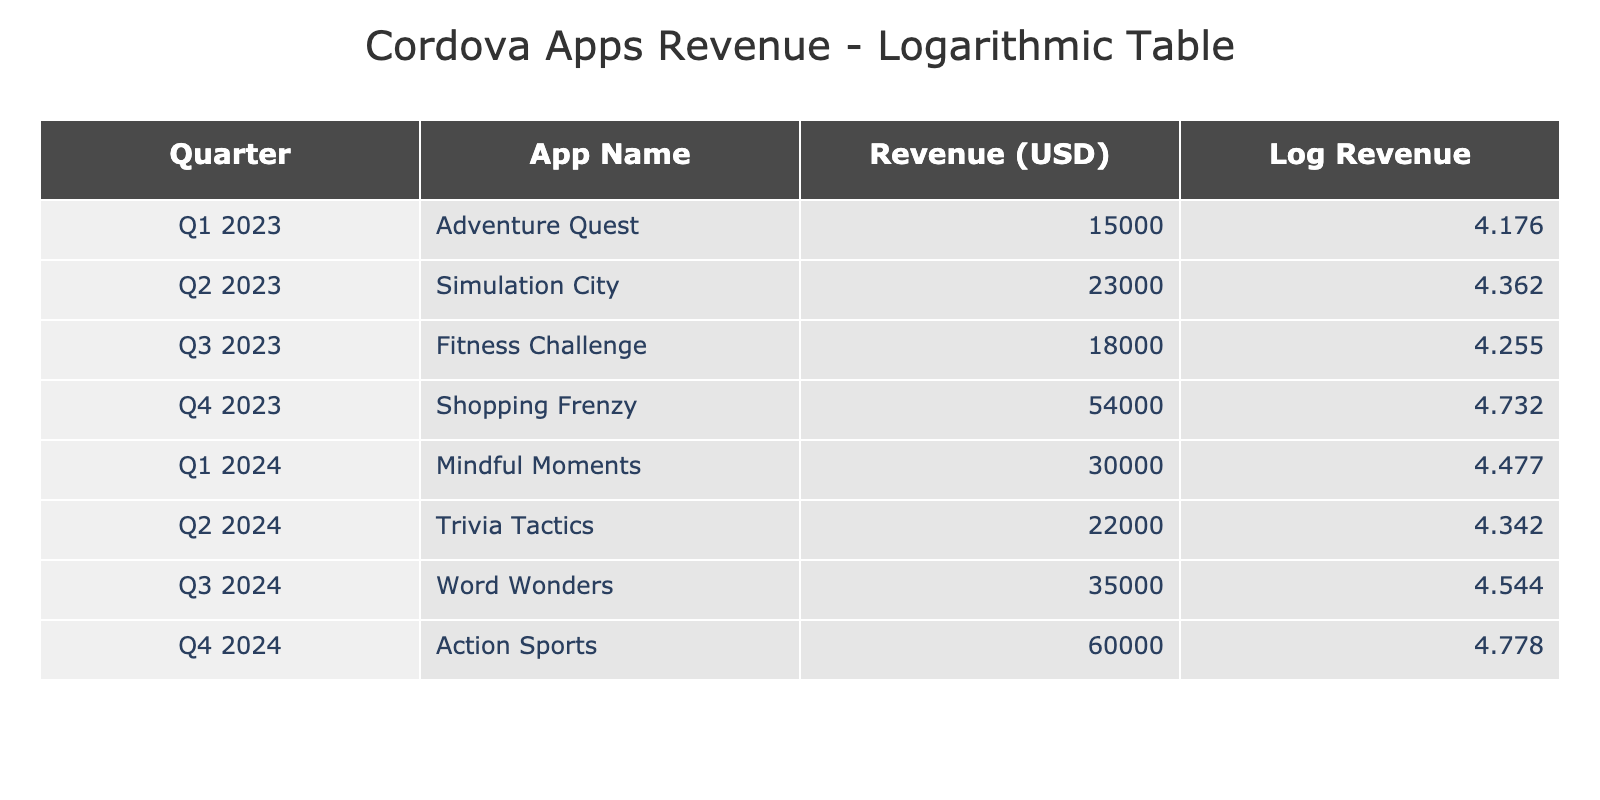What is the In-App Purchase Revenue for the app "Shopping Frenzy"? The table shows that for "Shopping Frenzy", the In-App Purchase Revenue is 54000 USD in Q4 2023.
Answer: 54000 USD Which app generated the highest revenue in Q1 2024? The app with the highest revenue in Q1 2024 is "Mindful Moments", with an In-App Purchase Revenue of 30000 USD.
Answer: Mindful Moments What is the total In-App Purchase Revenue across all quarters listed in the table? To find the total revenue, we sum the individual revenues from each app: 15000 + 23000 + 18000 + 54000 + 30000 + 22000 + 35000 + 60000 = 207000 USD.
Answer: 207000 USD Is "Fitness Challenge" revenue greater than that of "Trivia Tactics"? "Fitness Challenge" has a revenue of 18000 USD, whereas "Trivia Tactics" has a revenue of 22000 USD. Therefore, "Fitness Challenge" revenue is not greater.
Answer: No What was the average revenue from in-app purchases across Q2 2023 and Q2 2024? The revenues for these quarters are 23000 USD (Q2 2023) and 22000 USD (Q2 2024). The sum is 23000 + 22000 = 45000 USD, and the average is 45000/2 = 22500 USD.
Answer: 22500 USD Which quarter had the highest In-App Purchase Revenue? The highest In-App Purchase Revenue is found in Q4 2024 with 60000 USD, making it the quarter with the highest revenue according to the table.
Answer: Q4 2024 How many apps had an In-App Purchase Revenue above 25000 USD? The apps with revenue above 25000 USD are "Shopping Frenzy" (54000), "Mindful Moments" (30000), "Word Wonders" (35000), and "Action Sports" (60000). So, there are 4 apps in total.
Answer: 4 What is the difference in revenue between "Adventure Quest" and "Action Sports"? "Adventure Quest" has a revenue of 15000 USD and "Action Sports" has 60000 USD. The difference is 60000 - 15000 = 45000 USD.
Answer: 45000 USD Did "Word Wonders" generate more revenue than "Simulation City"? "Word Wonders" generated 35000 USD while "Simulation City" generated 23000 USD, thus "Word Wonders" generated more.
Answer: Yes 